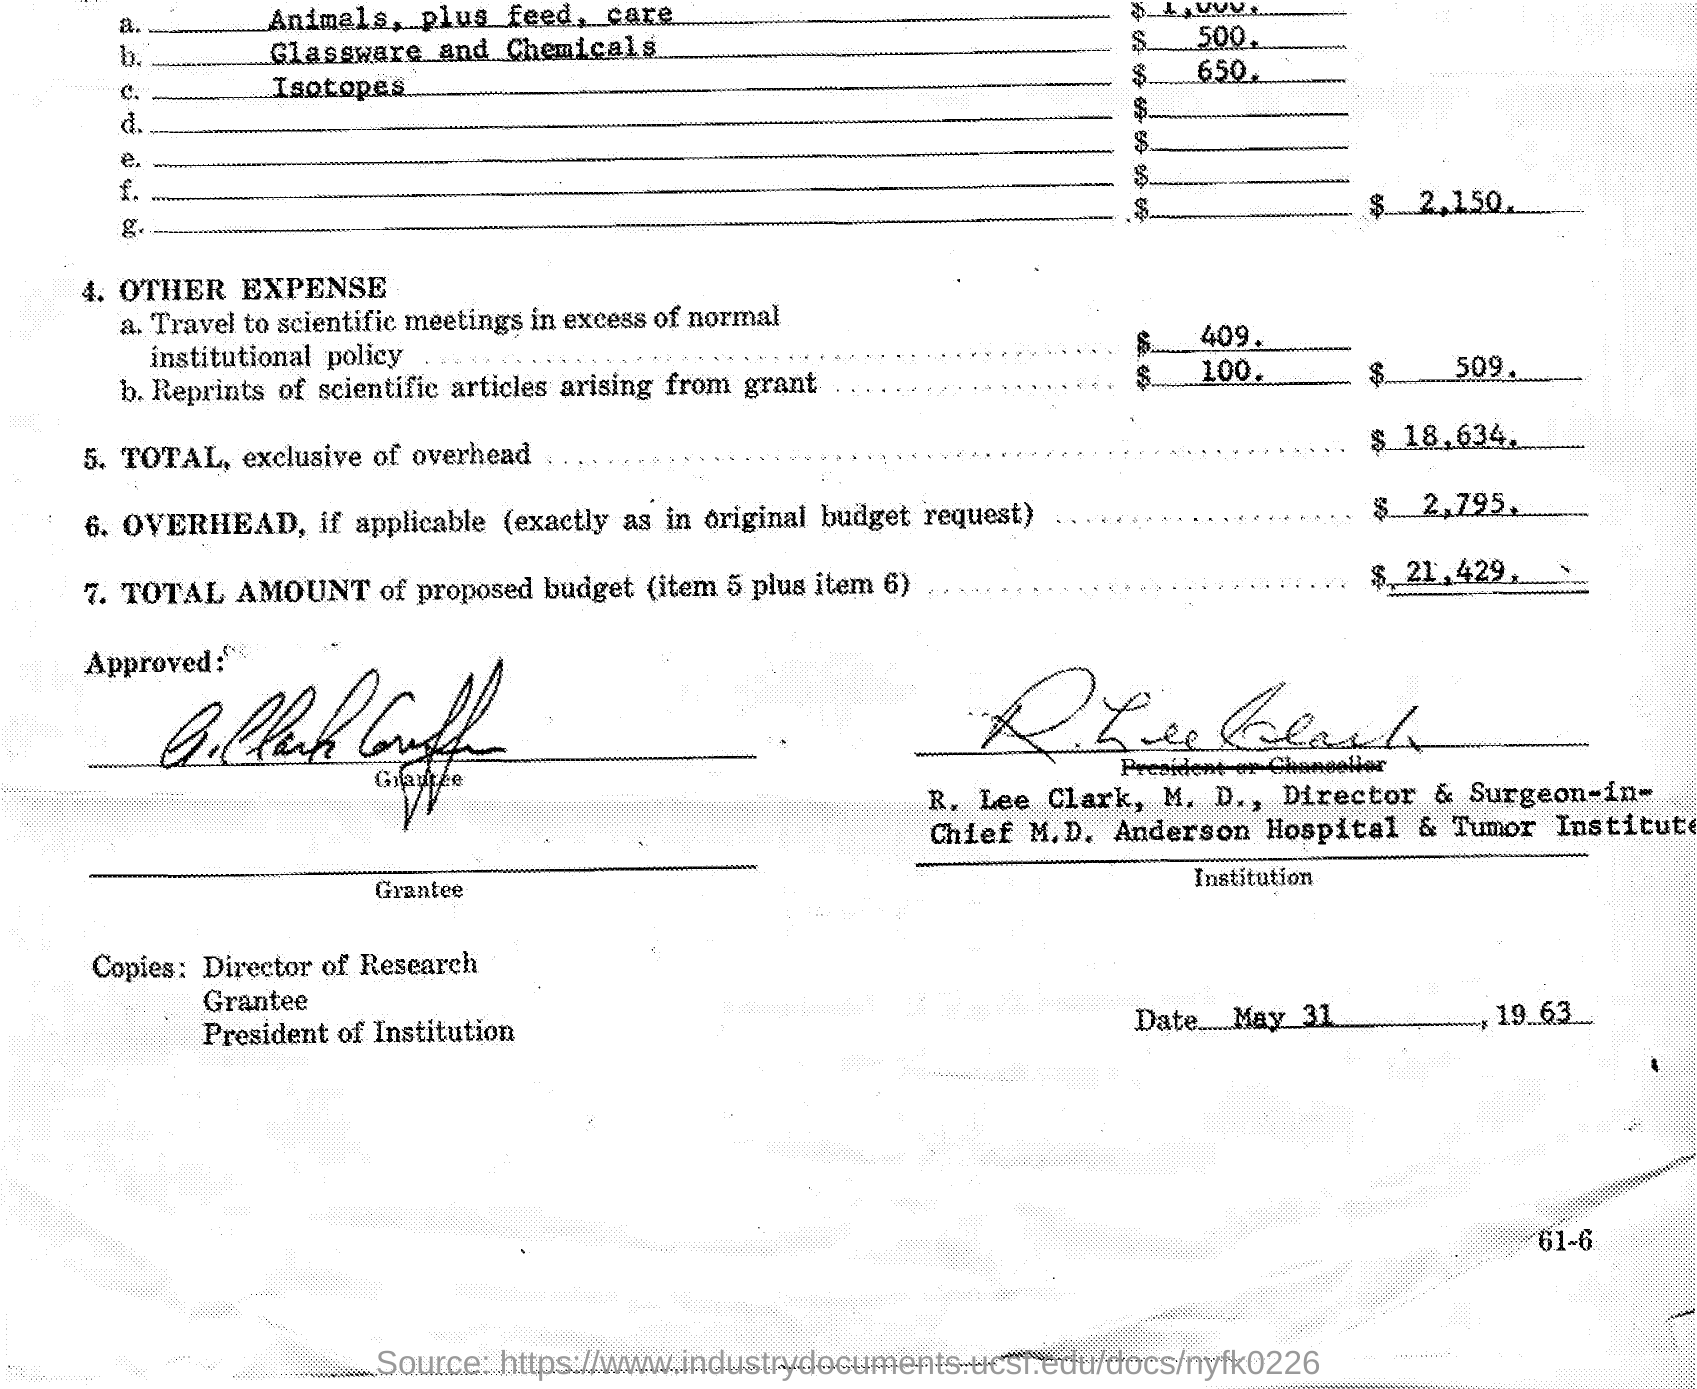When is the document dated?
Give a very brief answer. MAY 31, 1963. Which institution is mentioned?
Offer a very short reply. ANDERSON HOSPITAL & TUMOR INSTITUTE. 